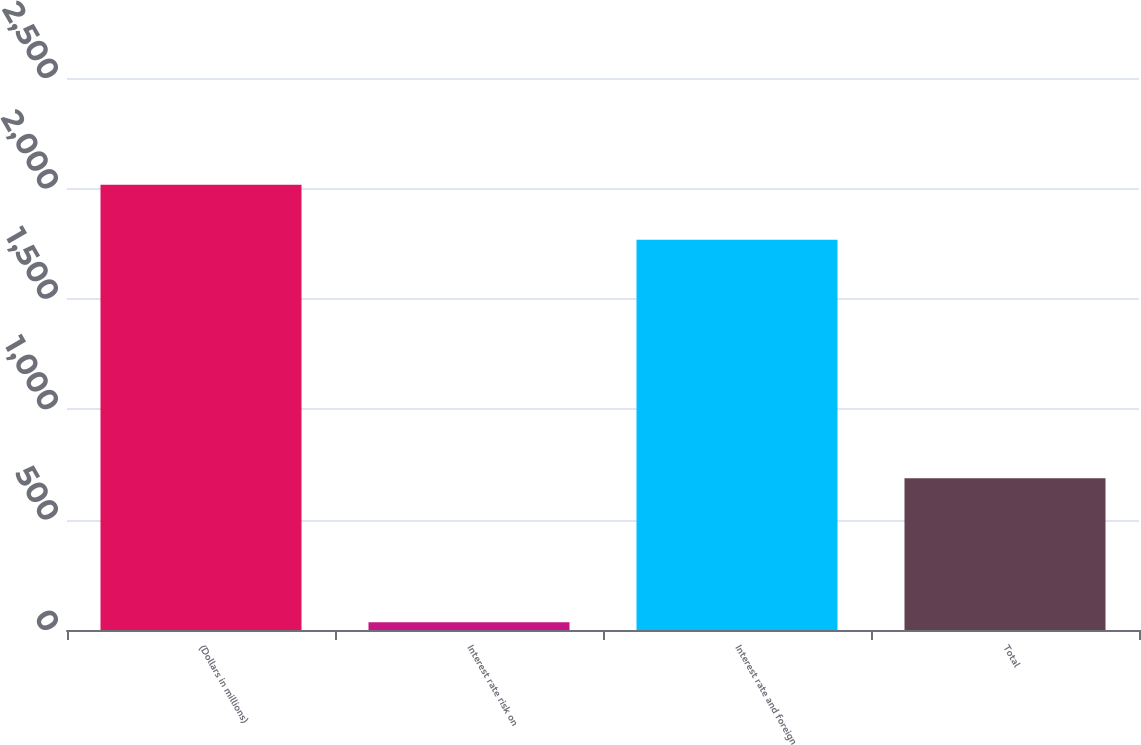Convert chart. <chart><loc_0><loc_0><loc_500><loc_500><bar_chart><fcel>(Dollars in millions)<fcel>Interest rate risk on<fcel>Interest rate and foreign<fcel>Total<nl><fcel>2017<fcel>35<fcel>1767<fcel>687<nl></chart> 